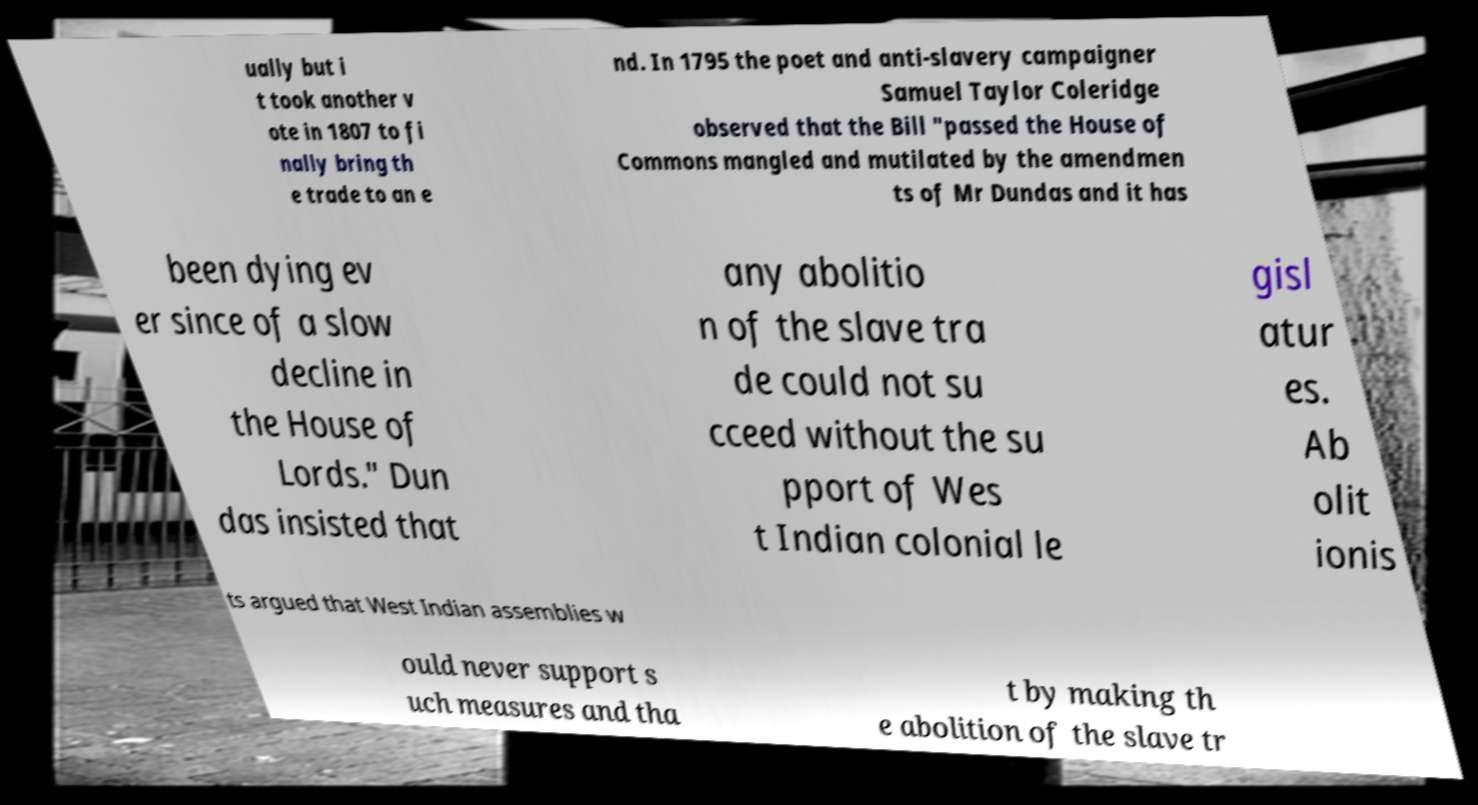There's text embedded in this image that I need extracted. Can you transcribe it verbatim? ually but i t took another v ote in 1807 to fi nally bring th e trade to an e nd. In 1795 the poet and anti-slavery campaigner Samuel Taylor Coleridge observed that the Bill "passed the House of Commons mangled and mutilated by the amendmen ts of Mr Dundas and it has been dying ev er since of a slow decline in the House of Lords." Dun das insisted that any abolitio n of the slave tra de could not su cceed without the su pport of Wes t Indian colonial le gisl atur es. Ab olit ionis ts argued that West Indian assemblies w ould never support s uch measures and tha t by making th e abolition of the slave tr 